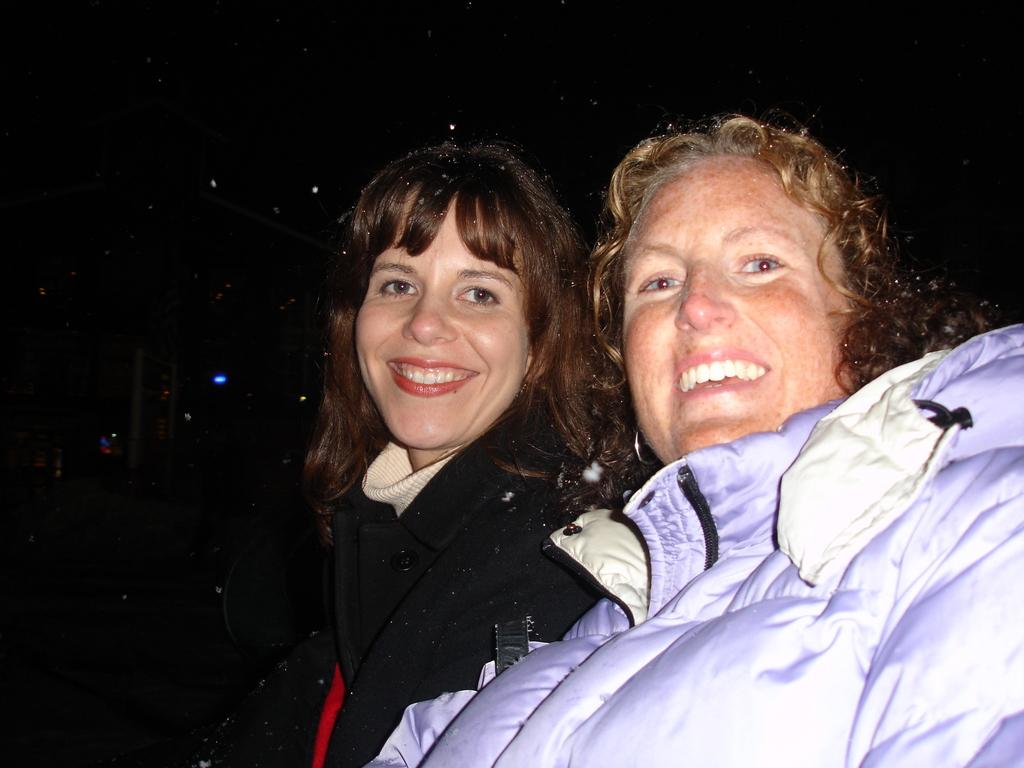What is the gender of the person in the image? There is a woman in the image. What is the woman wearing? The woman is wearing a black dress. What is the woman's facial expression? The woman is smiling. Can you describe the other person in the image? The other person is wearing a jacket and smiling. What is the color of the background in the image? The background of the image is dark. How many scarecrows can be seen in the image? There are no scarecrows present in the image. What type of rail is visible in the image? There is no rail visible in the image. 